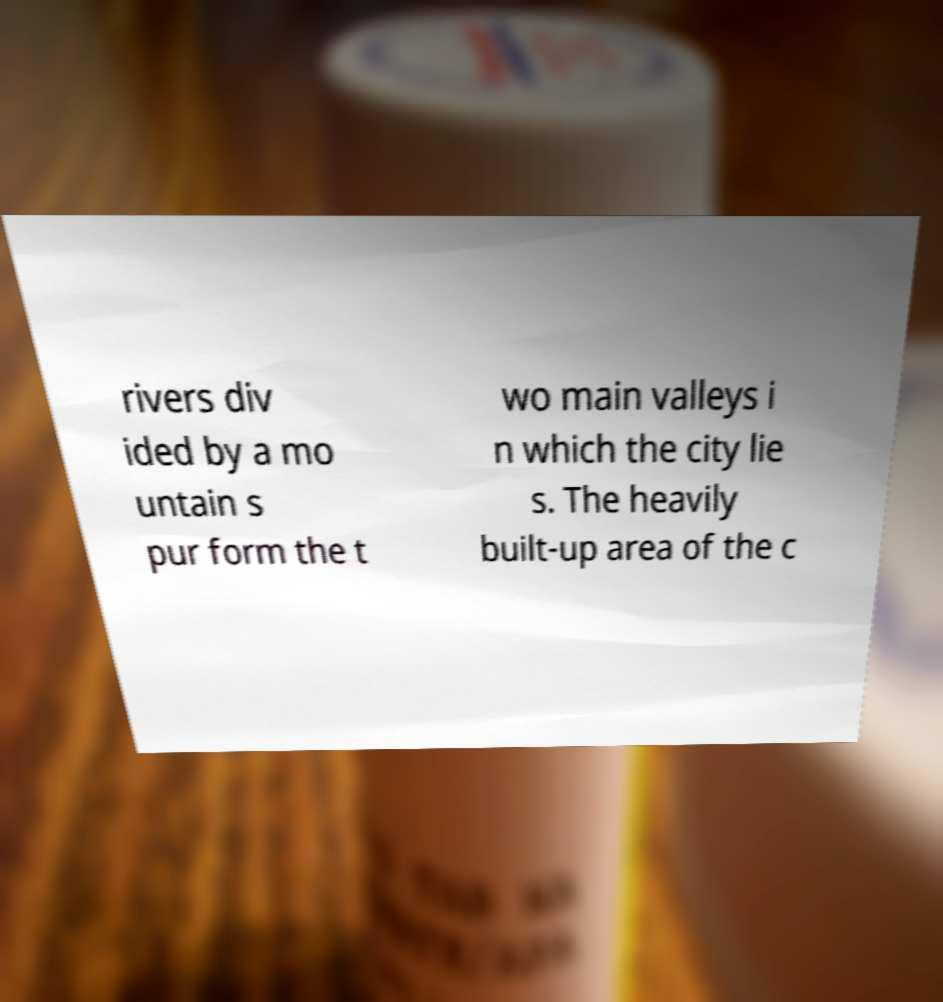Could you assist in decoding the text presented in this image and type it out clearly? rivers div ided by a mo untain s pur form the t wo main valleys i n which the city lie s. The heavily built-up area of the c 